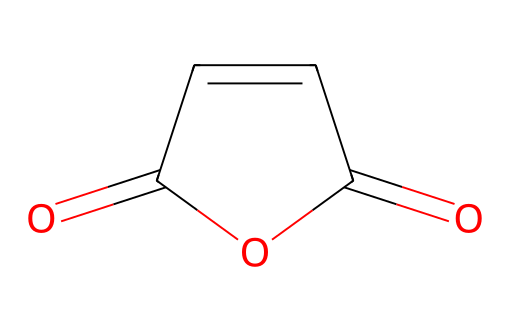What is the molecular formula of maleic anhydride? The molecular formula can be derived from counting the atoms in the given structure. The structure indicates 4 carbon atoms, 2 oxygen atoms, and 4 hydrogen atoms, resulting in the molecular formula C4H2O3.
Answer: C4H2O3 How many double bonds are present in maleic anhydride? By examining the structure, we can identify that there are two double bonds: one between two carbon atoms and one between a carbon atom and an oxygen atom (within the anhydride functional group).
Answer: 2 What type of functional groups are present in maleic anhydride? The structure shows the presence of an anhydride functional group, characterized by the two carbonyl (C=O) groups bonded to the same carbon atom, along with a carbon-carbon double bond.
Answer: anhydride How many carbon atoms are in the maleic anhydride structure? The structure contains 4 carbon atoms, which can be confirmed by directly counting the carbon symbols in the SMILES representation.
Answer: 4 What is the hybridization of the carbon atoms in maleic anhydride? The carbon atoms involved in the double bonds (C=C and C=O) are sp2 hybridized, while the carbon atoms in the anhydride portion are also sp2 due to their involvement in double bonds, confirming that all carbons are sp2 hybridized.
Answer: sp2 Is maleic anhydride a solid or liquid at room temperature? Maleic anhydride typically exists as a solid at room temperature, which can be deduced from its properties as a common compound used in various applications.
Answer: solid 